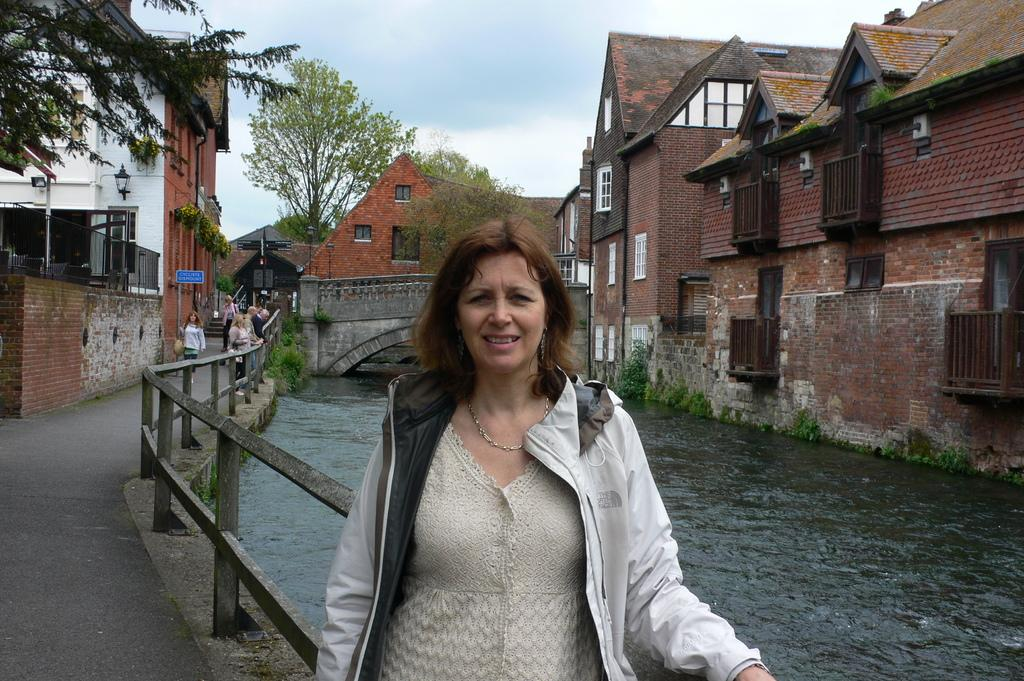What are the people in the image doing? The people in the image are standing on the road. What can be seen in the background of the image? There are buildings, trees, water, a bridge, the sky, and a fence visible in the background. What type of scissors can be seen cutting the grass in the image? There are no scissors or grass cutting activity present in the image. Can you tell me how many ghosts are visible in the image? There are no ghosts present in the image. 